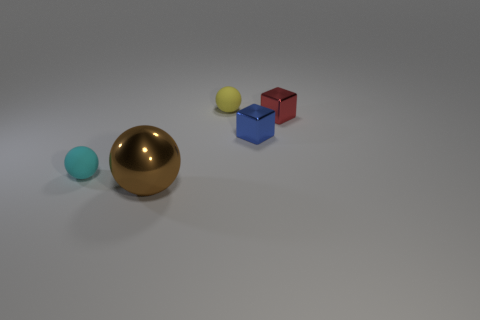What materials appear to be represented by the objects in the image? The objects in the image appear to represent different materials, such as metallic for the golden and blue cubes, glossy for the large blue sphere, and possibly matte or plastic for the small yellow and turquoise spheres. 